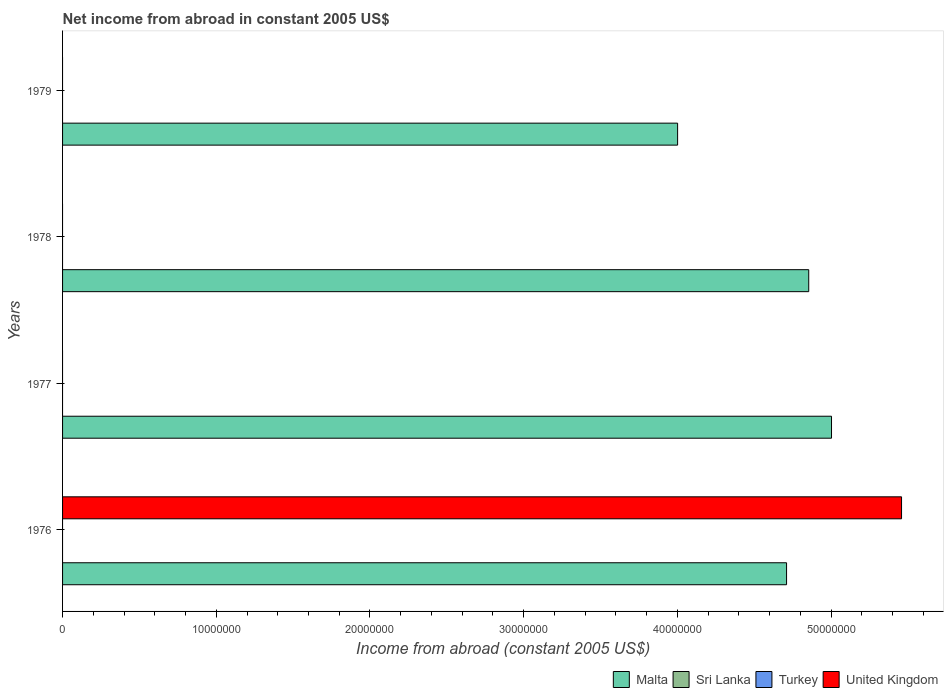Are the number of bars on each tick of the Y-axis equal?
Provide a succinct answer. No. How many bars are there on the 1st tick from the top?
Your answer should be compact. 1. What is the label of the 2nd group of bars from the top?
Provide a short and direct response. 1978. In how many cases, is the number of bars for a given year not equal to the number of legend labels?
Your answer should be compact. 4. What is the net income from abroad in United Kingdom in 1978?
Make the answer very short. 0. Across all years, what is the maximum net income from abroad in Malta?
Your answer should be very brief. 5.00e+07. Across all years, what is the minimum net income from abroad in United Kingdom?
Offer a very short reply. 0. In which year was the net income from abroad in United Kingdom maximum?
Keep it short and to the point. 1976. What is the difference between the net income from abroad in Malta in 1976 and that in 1977?
Keep it short and to the point. -2.92e+06. What is the difference between the net income from abroad in Turkey in 1978 and the net income from abroad in Sri Lanka in 1976?
Ensure brevity in your answer.  0. What is the average net income from abroad in Sri Lanka per year?
Offer a terse response. 0. What is the ratio of the net income from abroad in Malta in 1976 to that in 1979?
Offer a very short reply. 1.18. Is the net income from abroad in Malta in 1976 less than that in 1978?
Provide a short and direct response. Yes. What is the difference between the highest and the second highest net income from abroad in Malta?
Your answer should be compact. 1.48e+06. What is the difference between the highest and the lowest net income from abroad in Malta?
Give a very brief answer. 1.00e+07. In how many years, is the net income from abroad in Sri Lanka greater than the average net income from abroad in Sri Lanka taken over all years?
Your response must be concise. 0. Are all the bars in the graph horizontal?
Keep it short and to the point. Yes. What is the difference between two consecutive major ticks on the X-axis?
Your answer should be very brief. 1.00e+07. Are the values on the major ticks of X-axis written in scientific E-notation?
Give a very brief answer. No. Does the graph contain grids?
Ensure brevity in your answer.  No. How many legend labels are there?
Provide a short and direct response. 4. What is the title of the graph?
Provide a succinct answer. Net income from abroad in constant 2005 US$. What is the label or title of the X-axis?
Ensure brevity in your answer.  Income from abroad (constant 2005 US$). What is the label or title of the Y-axis?
Ensure brevity in your answer.  Years. What is the Income from abroad (constant 2005 US$) in Malta in 1976?
Keep it short and to the point. 4.71e+07. What is the Income from abroad (constant 2005 US$) in Turkey in 1976?
Provide a succinct answer. 0. What is the Income from abroad (constant 2005 US$) in United Kingdom in 1976?
Provide a short and direct response. 5.46e+07. What is the Income from abroad (constant 2005 US$) of Malta in 1977?
Offer a terse response. 5.00e+07. What is the Income from abroad (constant 2005 US$) of Sri Lanka in 1977?
Give a very brief answer. 0. What is the Income from abroad (constant 2005 US$) in Malta in 1978?
Your response must be concise. 4.85e+07. What is the Income from abroad (constant 2005 US$) in Turkey in 1978?
Provide a short and direct response. 0. What is the Income from abroad (constant 2005 US$) of Malta in 1979?
Offer a terse response. 4.00e+07. Across all years, what is the maximum Income from abroad (constant 2005 US$) in Malta?
Ensure brevity in your answer.  5.00e+07. Across all years, what is the maximum Income from abroad (constant 2005 US$) of United Kingdom?
Make the answer very short. 5.46e+07. Across all years, what is the minimum Income from abroad (constant 2005 US$) of Malta?
Your answer should be very brief. 4.00e+07. Across all years, what is the minimum Income from abroad (constant 2005 US$) in United Kingdom?
Your answer should be compact. 0. What is the total Income from abroad (constant 2005 US$) in Malta in the graph?
Keep it short and to the point. 1.86e+08. What is the total Income from abroad (constant 2005 US$) in Turkey in the graph?
Make the answer very short. 0. What is the total Income from abroad (constant 2005 US$) of United Kingdom in the graph?
Your answer should be compact. 5.46e+07. What is the difference between the Income from abroad (constant 2005 US$) in Malta in 1976 and that in 1977?
Provide a succinct answer. -2.92e+06. What is the difference between the Income from abroad (constant 2005 US$) in Malta in 1976 and that in 1978?
Ensure brevity in your answer.  -1.44e+06. What is the difference between the Income from abroad (constant 2005 US$) in Malta in 1976 and that in 1979?
Keep it short and to the point. 7.09e+06. What is the difference between the Income from abroad (constant 2005 US$) of Malta in 1977 and that in 1978?
Keep it short and to the point. 1.48e+06. What is the difference between the Income from abroad (constant 2005 US$) in Malta in 1977 and that in 1979?
Your response must be concise. 1.00e+07. What is the difference between the Income from abroad (constant 2005 US$) in Malta in 1978 and that in 1979?
Provide a short and direct response. 8.53e+06. What is the average Income from abroad (constant 2005 US$) in Malta per year?
Give a very brief answer. 4.64e+07. What is the average Income from abroad (constant 2005 US$) in Sri Lanka per year?
Ensure brevity in your answer.  0. What is the average Income from abroad (constant 2005 US$) of Turkey per year?
Offer a very short reply. 0. What is the average Income from abroad (constant 2005 US$) in United Kingdom per year?
Provide a succinct answer. 1.36e+07. In the year 1976, what is the difference between the Income from abroad (constant 2005 US$) in Malta and Income from abroad (constant 2005 US$) in United Kingdom?
Offer a terse response. -7.48e+06. What is the ratio of the Income from abroad (constant 2005 US$) of Malta in 1976 to that in 1977?
Give a very brief answer. 0.94. What is the ratio of the Income from abroad (constant 2005 US$) of Malta in 1976 to that in 1978?
Your answer should be compact. 0.97. What is the ratio of the Income from abroad (constant 2005 US$) in Malta in 1976 to that in 1979?
Keep it short and to the point. 1.18. What is the ratio of the Income from abroad (constant 2005 US$) in Malta in 1977 to that in 1978?
Keep it short and to the point. 1.03. What is the ratio of the Income from abroad (constant 2005 US$) of Malta in 1977 to that in 1979?
Keep it short and to the point. 1.25. What is the ratio of the Income from abroad (constant 2005 US$) of Malta in 1978 to that in 1979?
Your answer should be very brief. 1.21. What is the difference between the highest and the second highest Income from abroad (constant 2005 US$) in Malta?
Provide a short and direct response. 1.48e+06. What is the difference between the highest and the lowest Income from abroad (constant 2005 US$) in Malta?
Your answer should be very brief. 1.00e+07. What is the difference between the highest and the lowest Income from abroad (constant 2005 US$) in United Kingdom?
Your answer should be very brief. 5.46e+07. 